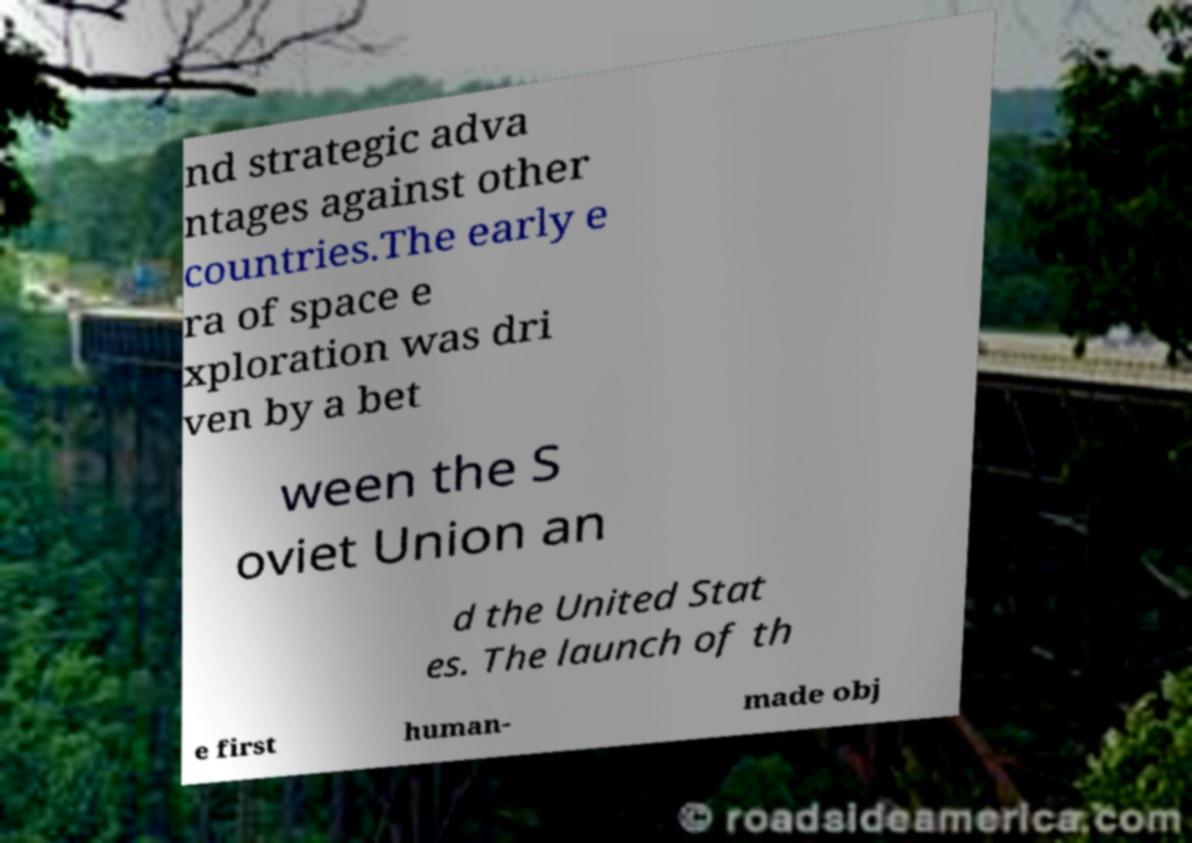There's text embedded in this image that I need extracted. Can you transcribe it verbatim? nd strategic adva ntages against other countries.The early e ra of space e xploration was dri ven by a bet ween the S oviet Union an d the United Stat es. The launch of th e first human- made obj 